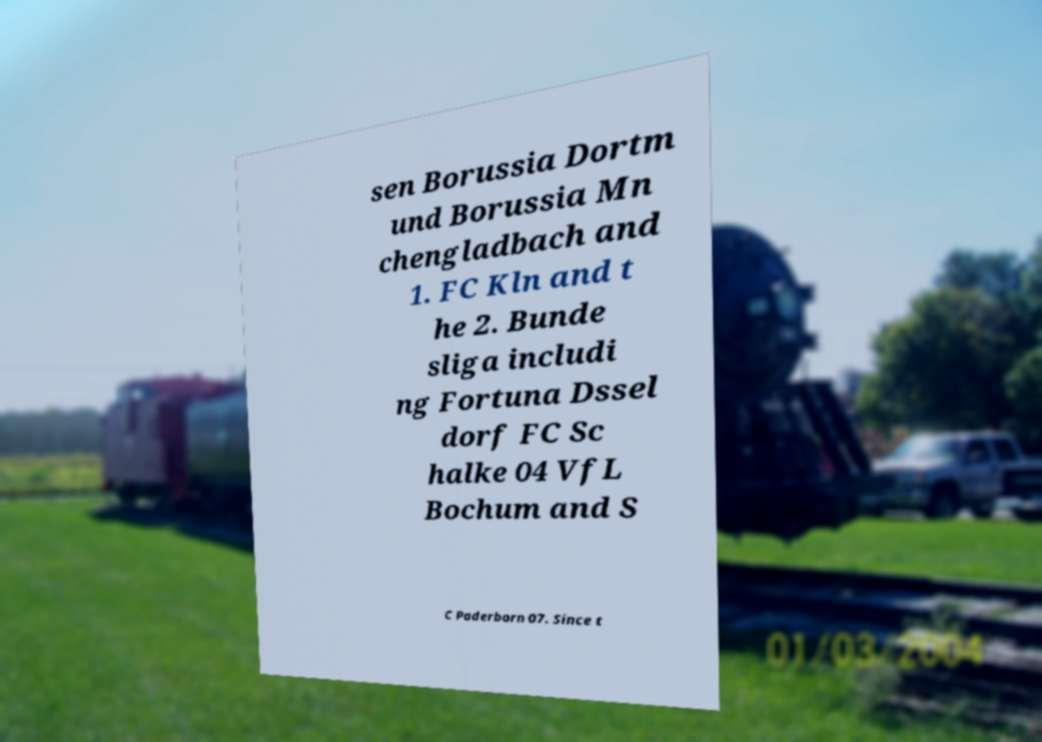There's text embedded in this image that I need extracted. Can you transcribe it verbatim? sen Borussia Dortm und Borussia Mn chengladbach and 1. FC Kln and t he 2. Bunde sliga includi ng Fortuna Dssel dorf FC Sc halke 04 VfL Bochum and S C Paderborn 07. Since t 